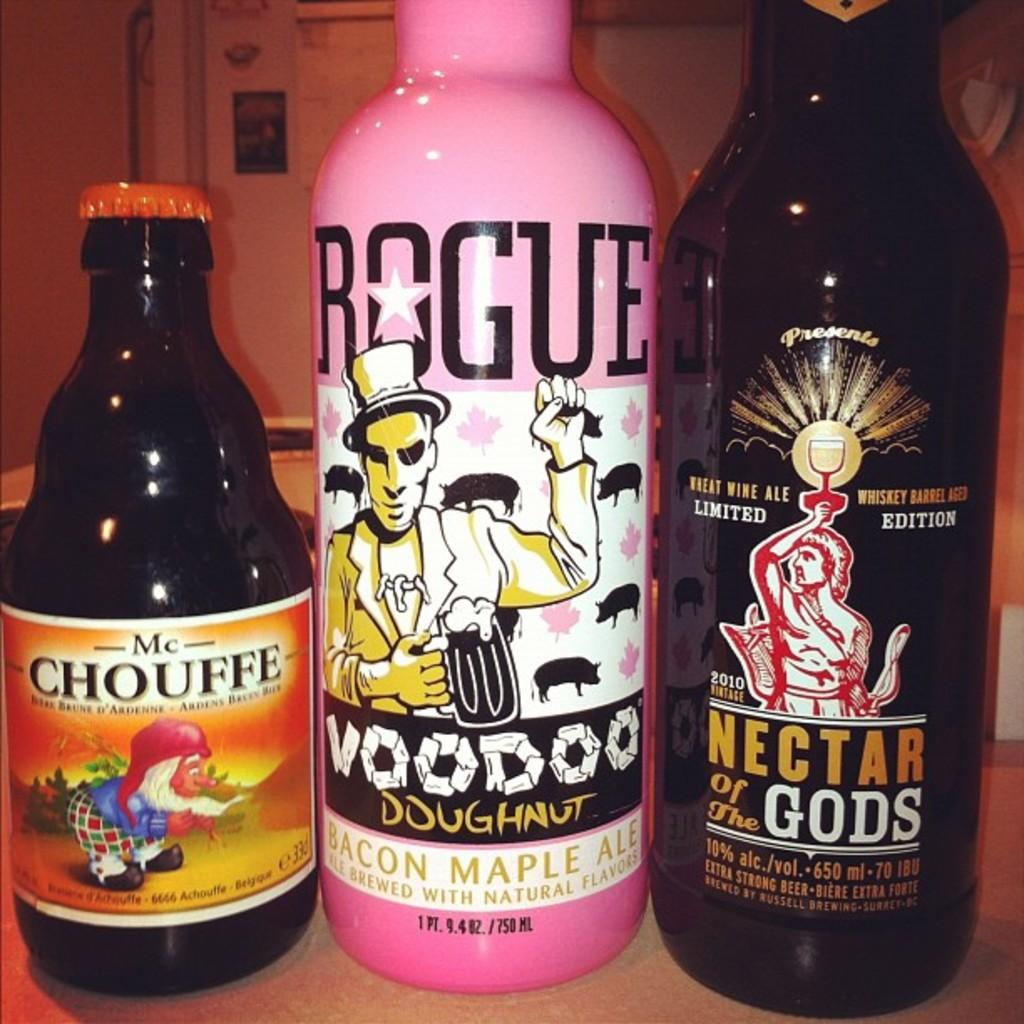Provide a one-sentence caption for the provided image. Three different beverages are next to each other, one of which is made by Rogue. 